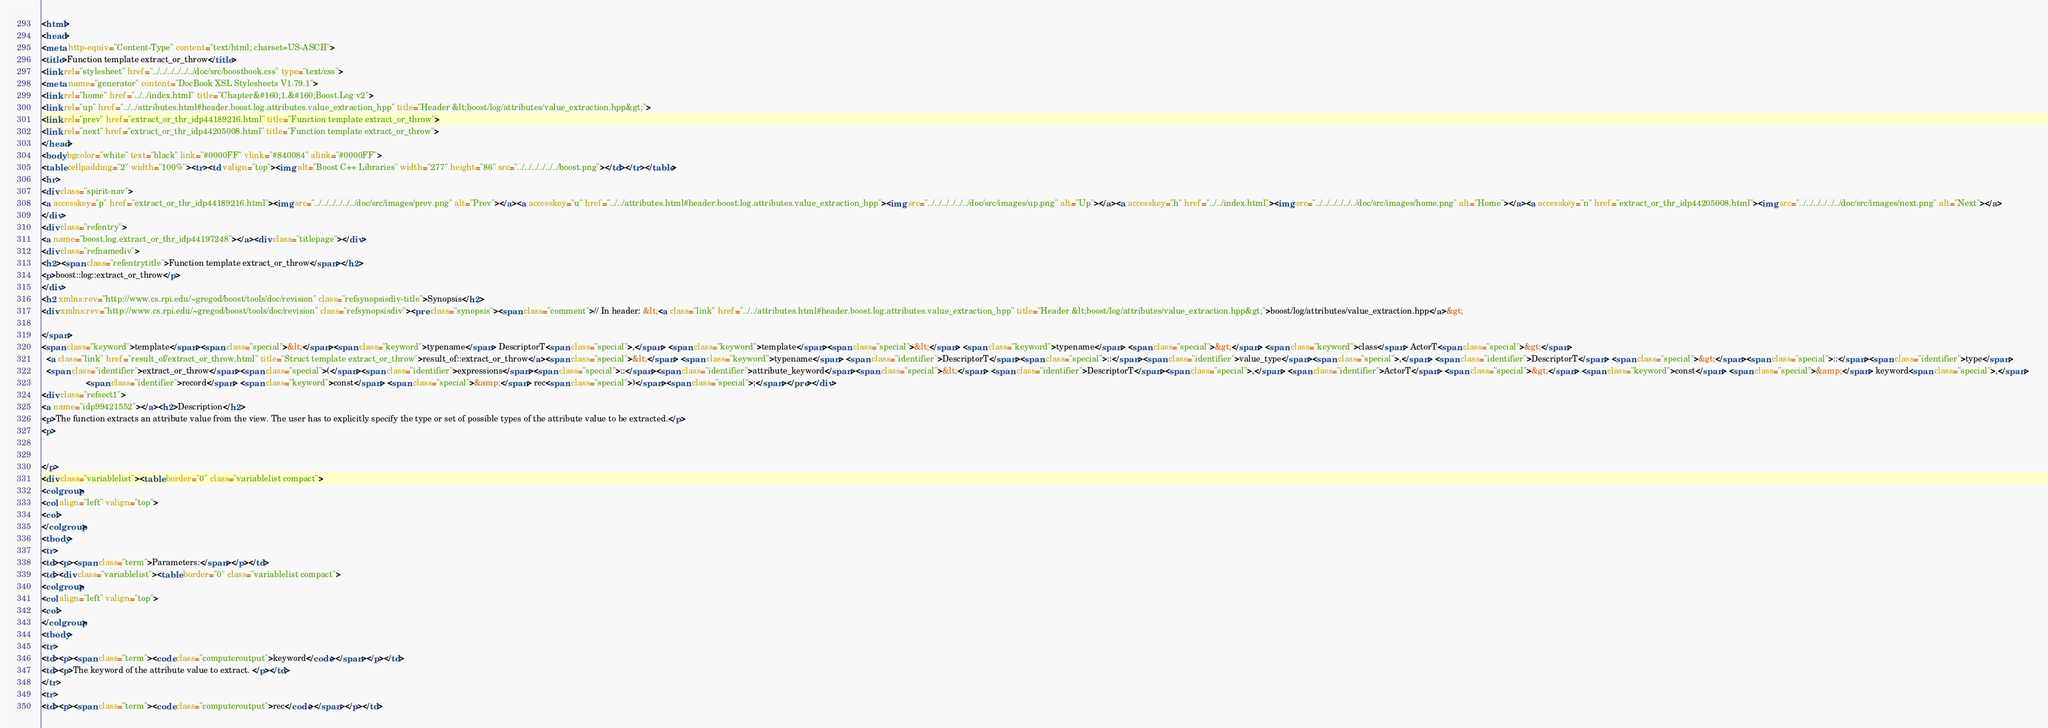Convert code to text. <code><loc_0><loc_0><loc_500><loc_500><_HTML_><html>
<head>
<meta http-equiv="Content-Type" content="text/html; charset=US-ASCII">
<title>Function template extract_or_throw</title>
<link rel="stylesheet" href="../../../../../../doc/src/boostbook.css" type="text/css">
<meta name="generator" content="DocBook XSL Stylesheets V1.79.1">
<link rel="home" href="../../index.html" title="Chapter&#160;1.&#160;Boost.Log v2">
<link rel="up" href="../../attributes.html#header.boost.log.attributes.value_extraction_hpp" title="Header &lt;boost/log/attributes/value_extraction.hpp&gt;">
<link rel="prev" href="extract_or_thr_idp44189216.html" title="Function template extract_or_throw">
<link rel="next" href="extract_or_thr_idp44205008.html" title="Function template extract_or_throw">
</head>
<body bgcolor="white" text="black" link="#0000FF" vlink="#840084" alink="#0000FF">
<table cellpadding="2" width="100%"><tr><td valign="top"><img alt="Boost C++ Libraries" width="277" height="86" src="../../../../../../boost.png"></td></tr></table>
<hr>
<div class="spirit-nav">
<a accesskey="p" href="extract_or_thr_idp44189216.html"><img src="../../../../../../doc/src/images/prev.png" alt="Prev"></a><a accesskey="u" href="../../attributes.html#header.boost.log.attributes.value_extraction_hpp"><img src="../../../../../../doc/src/images/up.png" alt="Up"></a><a accesskey="h" href="../../index.html"><img src="../../../../../../doc/src/images/home.png" alt="Home"></a><a accesskey="n" href="extract_or_thr_idp44205008.html"><img src="../../../../../../doc/src/images/next.png" alt="Next"></a>
</div>
<div class="refentry">
<a name="boost.log.extract_or_thr_idp44197248"></a><div class="titlepage"></div>
<div class="refnamediv">
<h2><span class="refentrytitle">Function template extract_or_throw</span></h2>
<p>boost::log::extract_or_throw</p>
</div>
<h2 xmlns:rev="http://www.cs.rpi.edu/~gregod/boost/tools/doc/revision" class="refsynopsisdiv-title">Synopsis</h2>
<div xmlns:rev="http://www.cs.rpi.edu/~gregod/boost/tools/doc/revision" class="refsynopsisdiv"><pre class="synopsis"><span class="comment">// In header: &lt;<a class="link" href="../../attributes.html#header.boost.log.attributes.value_extraction_hpp" title="Header &lt;boost/log/attributes/value_extraction.hpp&gt;">boost/log/attributes/value_extraction.hpp</a>&gt;

</span>
<span class="keyword">template</span><span class="special">&lt;</span><span class="keyword">typename</span> DescriptorT<span class="special">,</span> <span class="keyword">template</span><span class="special">&lt;</span> <span class="keyword">typename</span> <span class="special">&gt;</span> <span class="keyword">class</span> ActorT<span class="special">&gt;</span> 
  <a class="link" href="result_of/extract_or_throw.html" title="Struct template extract_or_throw">result_of::extract_or_throw</a><span class="special">&lt;</span> <span class="keyword">typename</span> <span class="identifier">DescriptorT</span><span class="special">::</span><span class="identifier">value_type</span><span class="special">,</span> <span class="identifier">DescriptorT</span> <span class="special">&gt;</span><span class="special">::</span><span class="identifier">type</span> 
  <span class="identifier">extract_or_throw</span><span class="special">(</span><span class="identifier">expressions</span><span class="special">::</span><span class="identifier">attribute_keyword</span><span class="special">&lt;</span> <span class="identifier">DescriptorT</span><span class="special">,</span> <span class="identifier">ActorT</span> <span class="special">&gt;</span> <span class="keyword">const</span> <span class="special">&amp;</span> keyword<span class="special">,</span> 
                   <span class="identifier">record</span> <span class="keyword">const</span> <span class="special">&amp;</span> rec<span class="special">)</span><span class="special">;</span></pre></div>
<div class="refsect1">
<a name="idp99421552"></a><h2>Description</h2>
<p>The function extracts an attribute value from the view. The user has to explicitly specify the type or set of possible types of the attribute value to be extracted.</p>
<p>


</p>
<div class="variablelist"><table border="0" class="variablelist compact">
<colgroup>
<col align="left" valign="top">
<col>
</colgroup>
<tbody>
<tr>
<td><p><span class="term">Parameters:</span></p></td>
<td><div class="variablelist"><table border="0" class="variablelist compact">
<colgroup>
<col align="left" valign="top">
<col>
</colgroup>
<tbody>
<tr>
<td><p><span class="term"><code class="computeroutput">keyword</code></span></p></td>
<td><p>The keyword of the attribute value to extract. </p></td>
</tr>
<tr>
<td><p><span class="term"><code class="computeroutput">rec</code></span></p></td></code> 